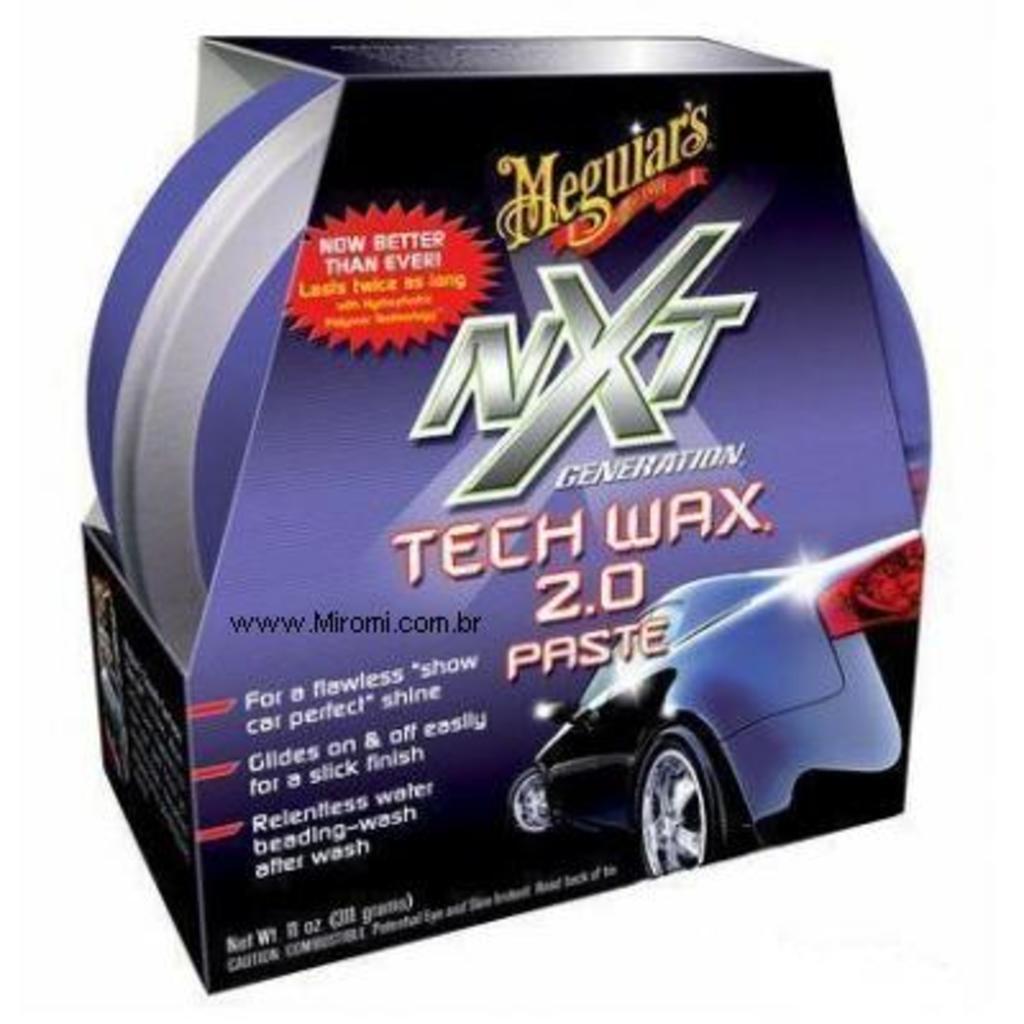Can you describe this image briefly? In this image I can see a box contain an object and on the box I can see the text and image of a car. 